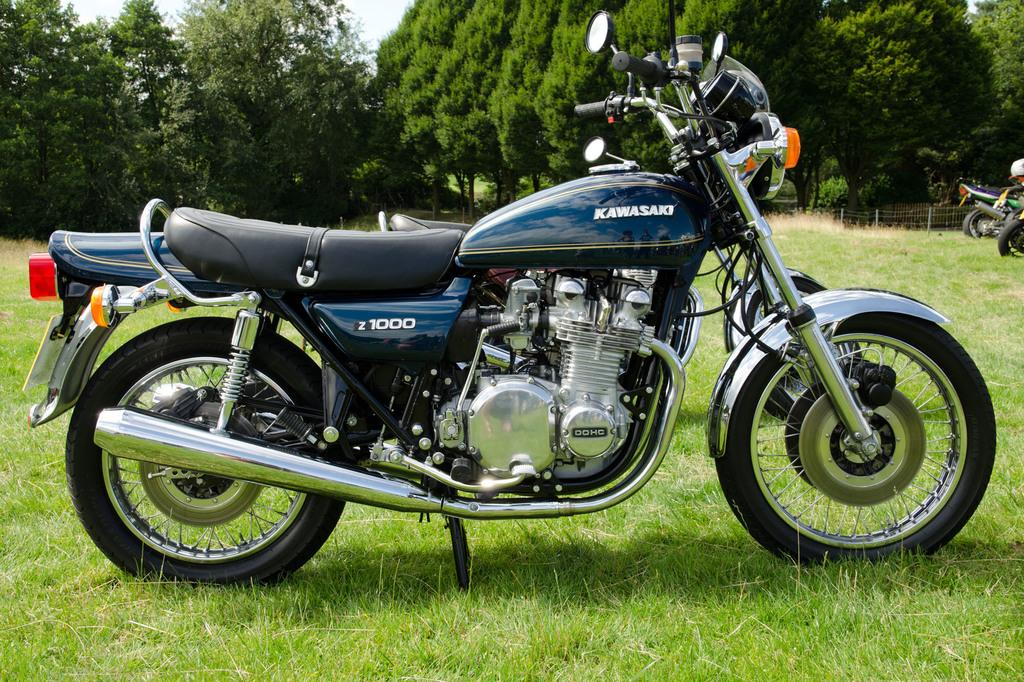What is parked on the grass in the image? There is a bike parked on the grass in the image. Can you describe any other bikes visible in the image? Yes, there are more bikes visible in the background. What can be seen in the background of the image? There is a fence and trees present in the background. What type of property is being sold in the image? There is no indication of any property being sold in the image; it primarily features bikes and a background with a fence and trees. 